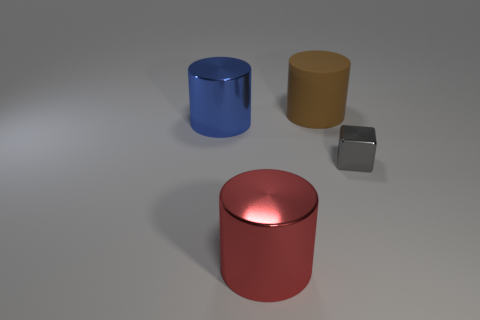Subtract 1 cylinders. How many cylinders are left? 2 Subtract all shiny cylinders. How many cylinders are left? 1 Add 3 red cylinders. How many objects exist? 7 Subtract all cylinders. How many objects are left? 1 Add 2 rubber cylinders. How many rubber cylinders exist? 3 Subtract 0 yellow balls. How many objects are left? 4 Subtract all green matte things. Subtract all large metal cylinders. How many objects are left? 2 Add 4 red things. How many red things are left? 5 